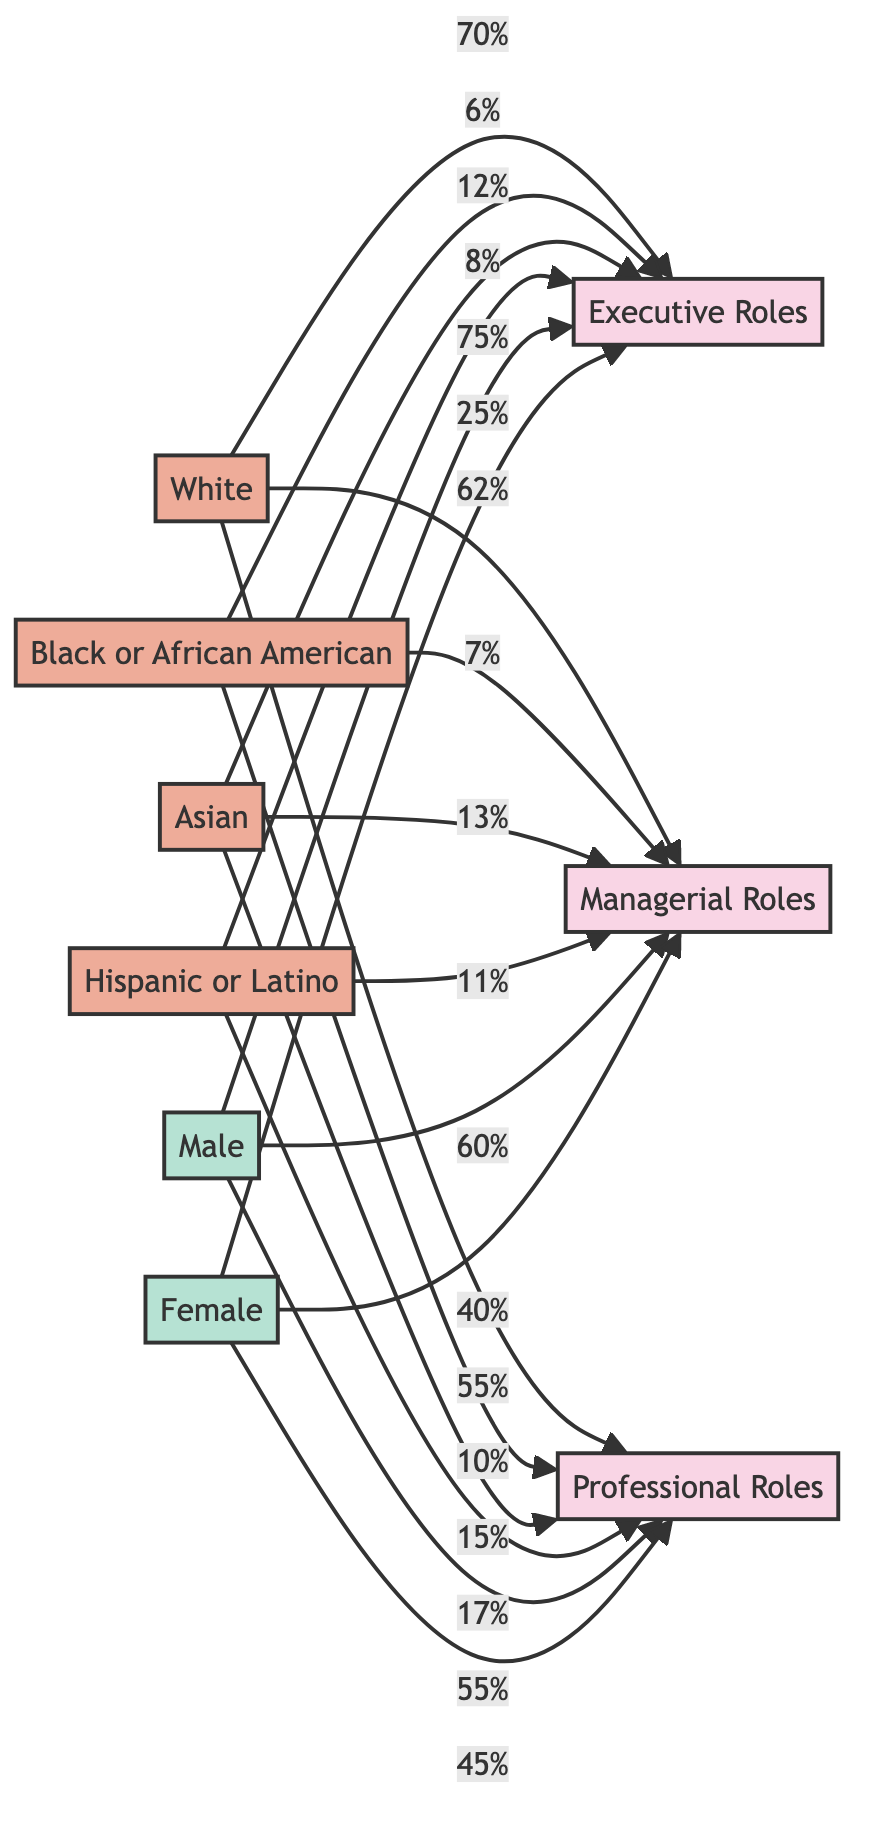What's the percentage of White individuals in Executive Roles? The diagram indicates that 70% of individuals in Executive Roles are White. We look at the edge connecting the White ethnicity node to the Executive Roles node, which shows the percentage directly.
Answer: 70% What is the representation of Black or African American individuals in Managerial Roles? In the diagram, there is a direct connection from the Black or African American node to the Managerial Roles node that shows a representation of 7%.
Answer: 7% How many distinct categories of workplace roles are represented in this diagram? The diagram consists of three distinct categories of workplace roles: Executive Roles, Managerial Roles, and Professional Roles. We count the nodes representing these roles.
Answer: 3 What percentage of Female individuals occupy Professional Roles? The Professional Roles node connects to the Female gender node, which indicates that 45% of Professional Roles are occupied by Females. This is obtained from examining the edge between these two nodes.
Answer: 45% Which gender has a higher representation in Executive Roles? Comparing the percentages connected to the Executive Roles node, 75% of the roles are occupied by Males, while only 25% are Females. Hence, Males have a higher representation.
Answer: Male What is the combined percentage of Asian individuals in all roles? To find the combined percentage, we add the contributions of Asian individuals across all roles: 12% in Executive Roles, 13% in Managerial Roles, and 15% in Professional Roles. This totals 40%.
Answer: 40% Which ethnic group has the highest representation in Professional Roles? By reviewing the percentages under the Professional Roles node, we see that Hispanic or Latino individuals constitute 17%, which is the highest percentage among the ethnic groups listed.
Answer: Hispanic or Latino What proportion of Managerial Roles is filled by Females? The edge from the Female gender node to the Managerial Roles node indicates that 40% of Managerial Roles are filled by Females. We read the percentage directly off the diagram flow.
Answer: 40% How do the percentages of White individuals in Executive and Professional Roles compare? The percentage of White individuals in Executive Roles is 70% and in Professional Roles is 55%. Comparing these numbers shows that 70% is higher than 55%.
Answer: 70% is greater than 55% 